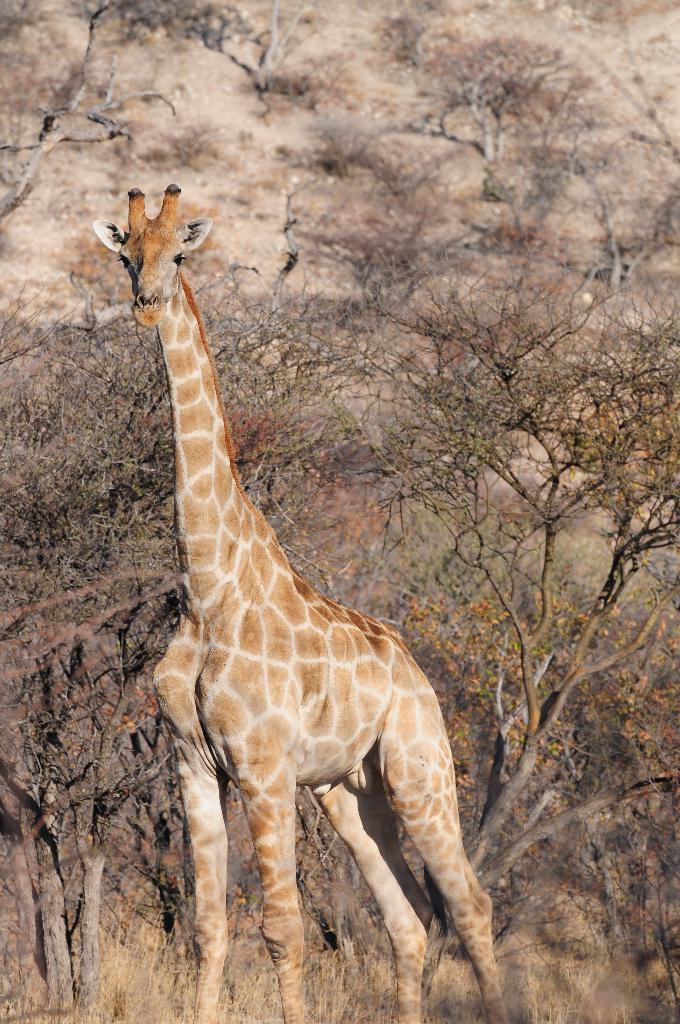What animal is in the center of the image? There is a giraffe in the center of the image. What is the giraffe doing in the image? The giraffe is standing in the image. What can be seen in the background of the image? There are trees in the background of the image. What type of liquid can be seen flowing through the river in the image? There is no river present in the image, so it is not possible to determine what type of liquid might be flowing through it. 